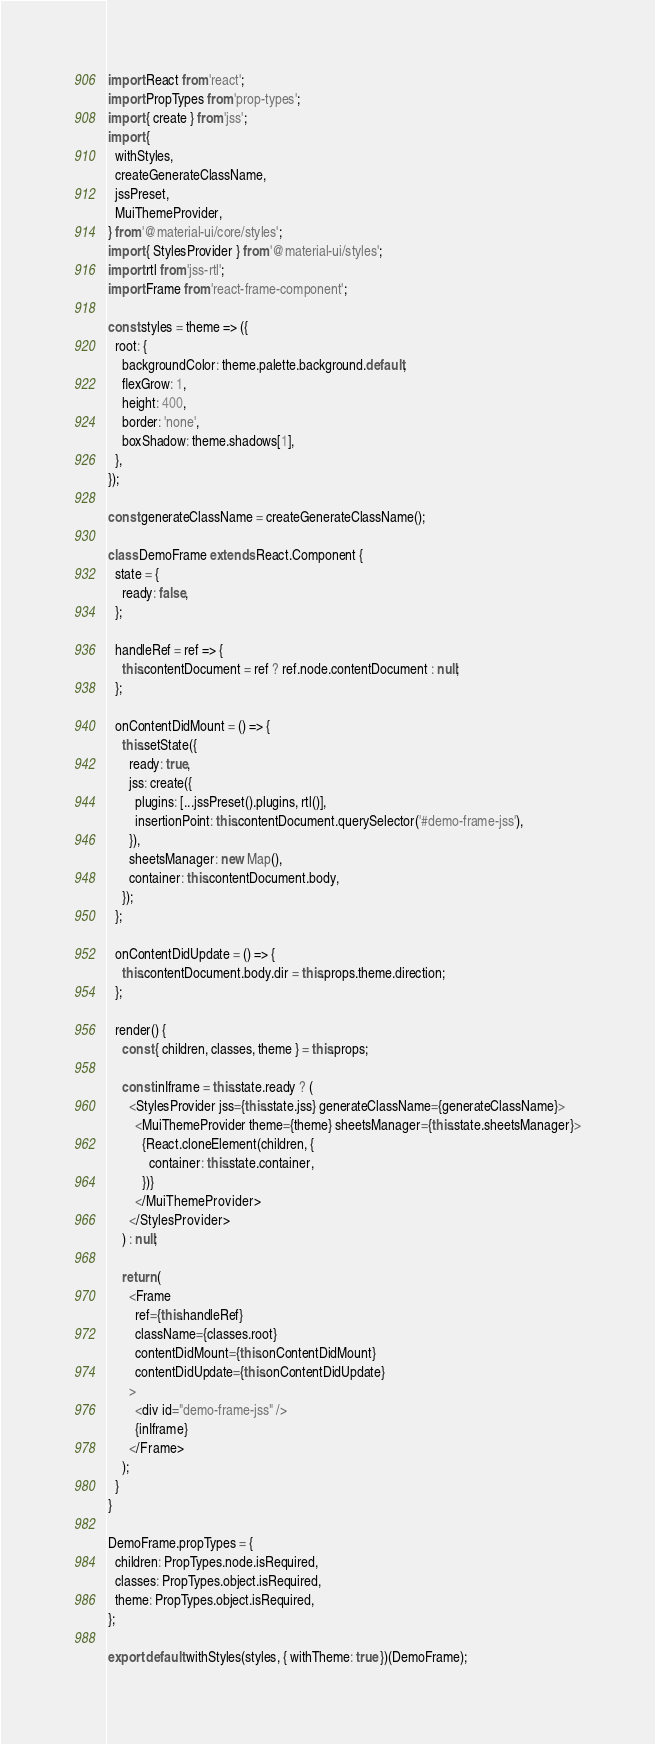Convert code to text. <code><loc_0><loc_0><loc_500><loc_500><_JavaScript_>import React from 'react';
import PropTypes from 'prop-types';
import { create } from 'jss';
import {
  withStyles,
  createGenerateClassName,
  jssPreset,
  MuiThemeProvider,
} from '@material-ui/core/styles';
import { StylesProvider } from '@material-ui/styles';
import rtl from 'jss-rtl';
import Frame from 'react-frame-component';

const styles = theme => ({
  root: {
    backgroundColor: theme.palette.background.default,
    flexGrow: 1,
    height: 400,
    border: 'none',
    boxShadow: theme.shadows[1],
  },
});

const generateClassName = createGenerateClassName();

class DemoFrame extends React.Component {
  state = {
    ready: false,
  };

  handleRef = ref => {
    this.contentDocument = ref ? ref.node.contentDocument : null;
  };

  onContentDidMount = () => {
    this.setState({
      ready: true,
      jss: create({
        plugins: [...jssPreset().plugins, rtl()],
        insertionPoint: this.contentDocument.querySelector('#demo-frame-jss'),
      }),
      sheetsManager: new Map(),
      container: this.contentDocument.body,
    });
  };

  onContentDidUpdate = () => {
    this.contentDocument.body.dir = this.props.theme.direction;
  };

  render() {
    const { children, classes, theme } = this.props;

    const inIframe = this.state.ready ? (
      <StylesProvider jss={this.state.jss} generateClassName={generateClassName}>
        <MuiThemeProvider theme={theme} sheetsManager={this.state.sheetsManager}>
          {React.cloneElement(children, {
            container: this.state.container,
          })}
        </MuiThemeProvider>
      </StylesProvider>
    ) : null;

    return (
      <Frame
        ref={this.handleRef}
        className={classes.root}
        contentDidMount={this.onContentDidMount}
        contentDidUpdate={this.onContentDidUpdate}
      >
        <div id="demo-frame-jss" />
        {inIframe}
      </Frame>
    );
  }
}

DemoFrame.propTypes = {
  children: PropTypes.node.isRequired,
  classes: PropTypes.object.isRequired,
  theme: PropTypes.object.isRequired,
};

export default withStyles(styles, { withTheme: true })(DemoFrame);
</code> 